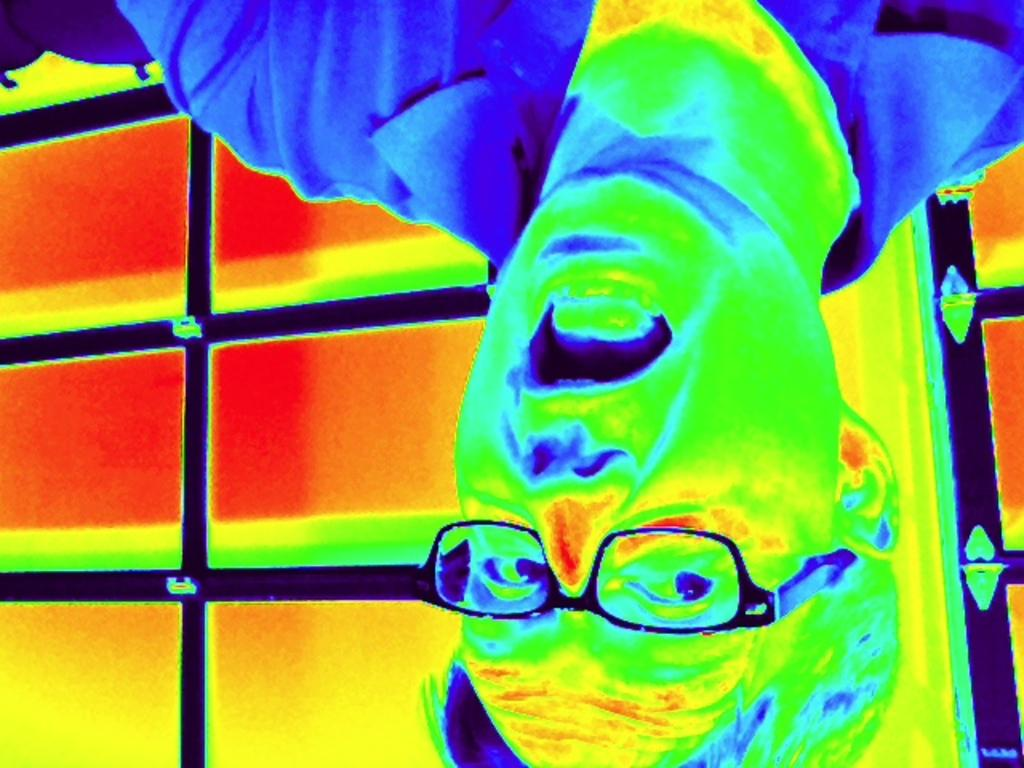Who is present in the image? There is a man in the image. What object can be seen in the image? There is an iron grill in the image. Where is the iron grill located in relation to the man? The iron grill is located on the backside of the man. What type of fiction is the man reading in the image? There is no book or any form of fiction present in the image. 